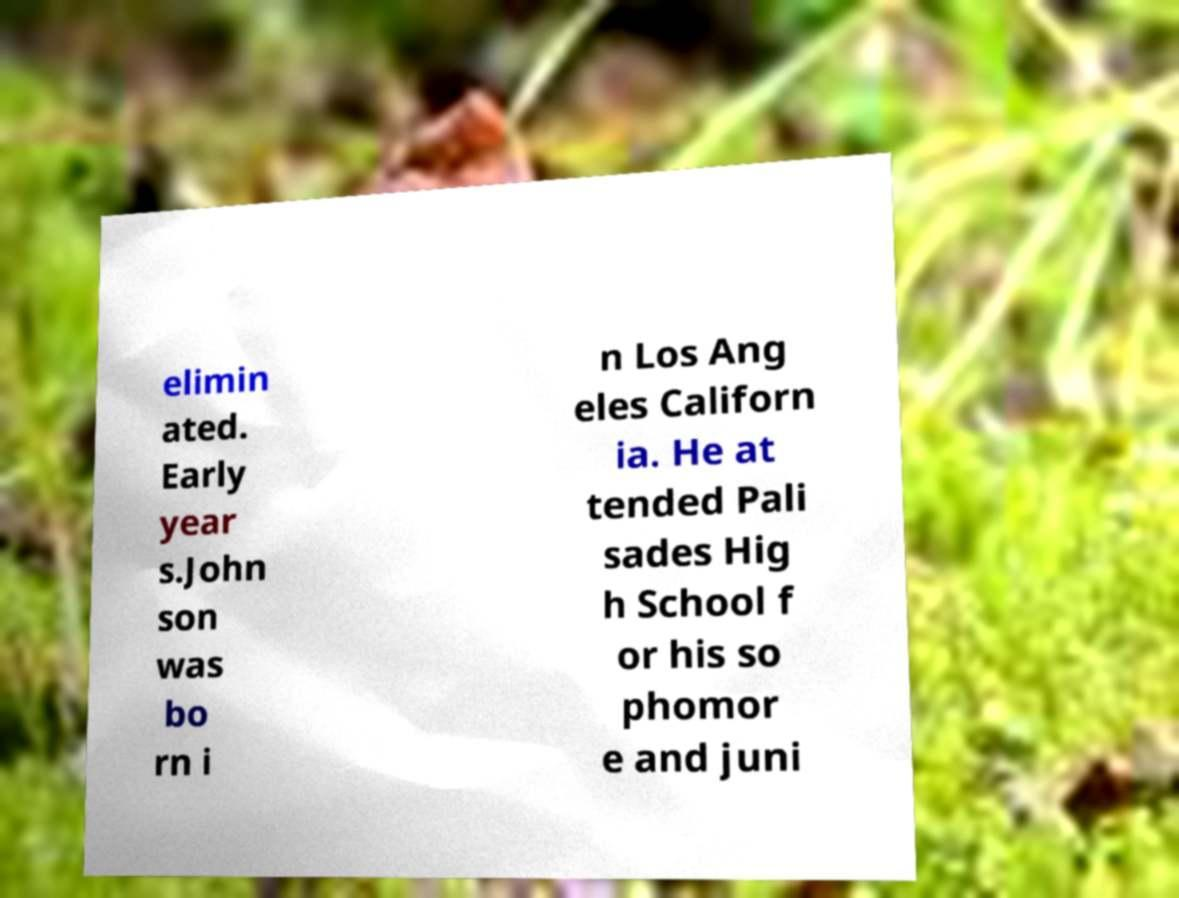Could you assist in decoding the text presented in this image and type it out clearly? elimin ated. Early year s.John son was bo rn i n Los Ang eles Californ ia. He at tended Pali sades Hig h School f or his so phomor e and juni 